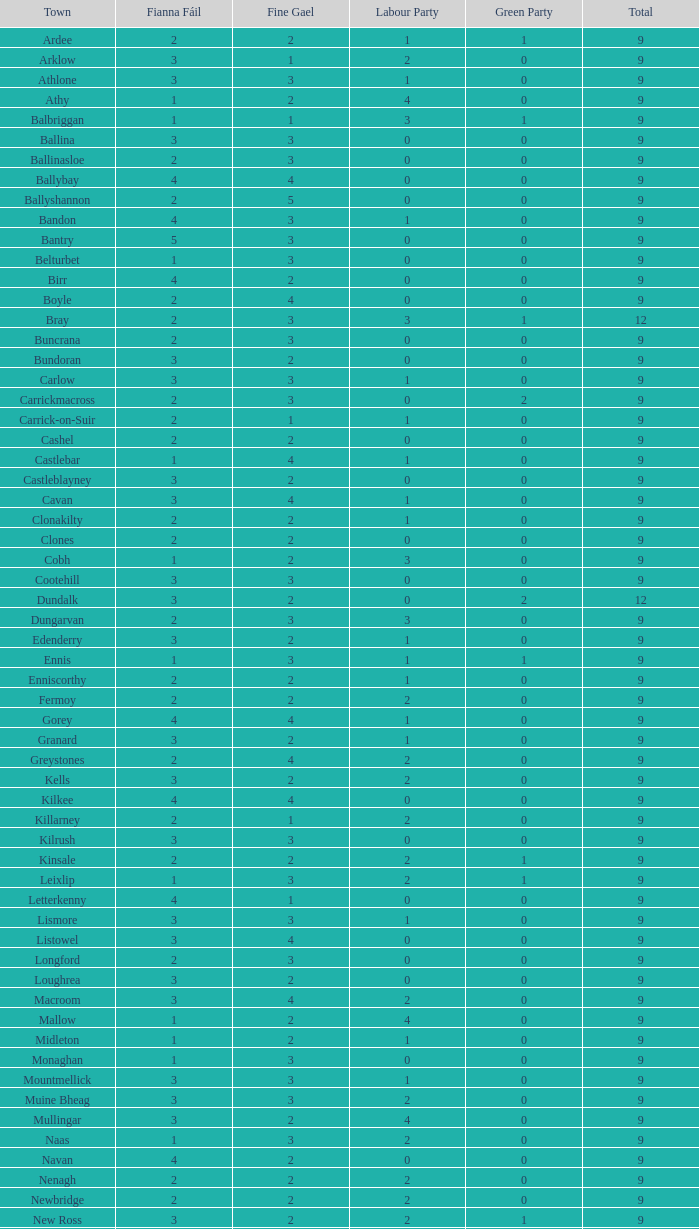Parse the full table. {'header': ['Town', 'Fianna Fáil', 'Fine Gael', 'Labour Party', 'Green Party', 'Total'], 'rows': [['Ardee', '2', '2', '1', '1', '9'], ['Arklow', '3', '1', '2', '0', '9'], ['Athlone', '3', '3', '1', '0', '9'], ['Athy', '1', '2', '4', '0', '9'], ['Balbriggan', '1', '1', '3', '1', '9'], ['Ballina', '3', '3', '0', '0', '9'], ['Ballinasloe', '2', '3', '0', '0', '9'], ['Ballybay', '4', '4', '0', '0', '9'], ['Ballyshannon', '2', '5', '0', '0', '9'], ['Bandon', '4', '3', '1', '0', '9'], ['Bantry', '5', '3', '0', '0', '9'], ['Belturbet', '1', '3', '0', '0', '9'], ['Birr', '4', '2', '0', '0', '9'], ['Boyle', '2', '4', '0', '0', '9'], ['Bray', '2', '3', '3', '1', '12'], ['Buncrana', '2', '3', '0', '0', '9'], ['Bundoran', '3', '2', '0', '0', '9'], ['Carlow', '3', '3', '1', '0', '9'], ['Carrickmacross', '2', '3', '0', '2', '9'], ['Carrick-on-Suir', '2', '1', '1', '0', '9'], ['Cashel', '2', '2', '0', '0', '9'], ['Castlebar', '1', '4', '1', '0', '9'], ['Castleblayney', '3', '2', '0', '0', '9'], ['Cavan', '3', '4', '1', '0', '9'], ['Clonakilty', '2', '2', '1', '0', '9'], ['Clones', '2', '2', '0', '0', '9'], ['Cobh', '1', '2', '3', '0', '9'], ['Cootehill', '3', '3', '0', '0', '9'], ['Dundalk', '3', '2', '0', '2', '12'], ['Dungarvan', '2', '3', '3', '0', '9'], ['Edenderry', '3', '2', '1', '0', '9'], ['Ennis', '1', '3', '1', '1', '9'], ['Enniscorthy', '2', '2', '1', '0', '9'], ['Fermoy', '2', '2', '2', '0', '9'], ['Gorey', '4', '4', '1', '0', '9'], ['Granard', '3', '2', '1', '0', '9'], ['Greystones', '2', '4', '2', '0', '9'], ['Kells', '3', '2', '2', '0', '9'], ['Kilkee', '4', '4', '0', '0', '9'], ['Killarney', '2', '1', '2', '0', '9'], ['Kilrush', '3', '3', '0', '0', '9'], ['Kinsale', '2', '2', '2', '1', '9'], ['Leixlip', '1', '3', '2', '1', '9'], ['Letterkenny', '4', '1', '0', '0', '9'], ['Lismore', '3', '3', '1', '0', '9'], ['Listowel', '3', '4', '0', '0', '9'], ['Longford', '2', '3', '0', '0', '9'], ['Loughrea', '3', '2', '0', '0', '9'], ['Macroom', '3', '4', '2', '0', '9'], ['Mallow', '1', '2', '4', '0', '9'], ['Midleton', '1', '2', '1', '0', '9'], ['Monaghan', '1', '3', '0', '0', '9'], ['Mountmellick', '3', '3', '1', '0', '9'], ['Muine Bheag', '3', '3', '2', '0', '9'], ['Mullingar', '3', '2', '4', '0', '9'], ['Naas', '1', '3', '2', '0', '9'], ['Navan', '4', '2', '0', '0', '9'], ['Nenagh', '2', '2', '2', '0', '9'], ['Newbridge', '2', '2', '2', '0', '9'], ['New Ross', '3', '2', '2', '1', '9'], ['Passage West', '2', '3', '0', '0', '9'], ['Portlaoise', '2', '3', '0', '0', '9'], ['Shannon', '0', '4', '2', '0', '9'], ['Skibbereen', '2', '4', '2', '0', '9'], ['Templemore', '3', '3', '0', '0', '9'], ['Thurles', '1', '1', '2', '0', '9'], ['Tipperary', '3', '1', '1', '0', '9'], ['Tralee', '2', '3', '3', '0', '12'], ['Tramore', '1', '4', '1', '0', '9'], ['Trim', '2', '3', '2', '0', '9'], ['Tuam', '3', '2', '2', '0', '9'], ['Tullamore', '4', '2', '2', '0', '9'], ['Westport', '2', '5', '1', '0', '9'], ['Wicklow', '1', '3', '1', '1', '9'], ['Youghal', '3', '2', '1', '1', '9']]} How many are in the labour party of a fianna fail of 3 with a total exceeding 9 and over 2 in the green party? None. 